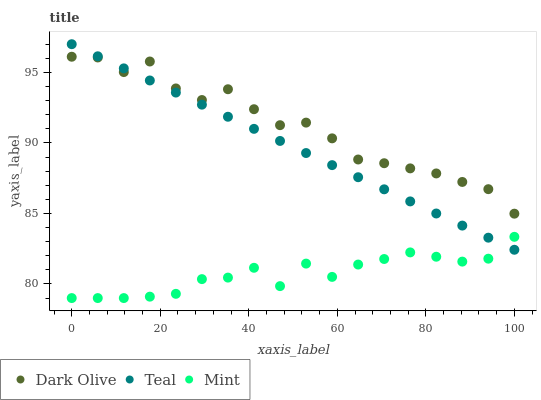Does Mint have the minimum area under the curve?
Answer yes or no. Yes. Does Dark Olive have the maximum area under the curve?
Answer yes or no. Yes. Does Teal have the minimum area under the curve?
Answer yes or no. No. Does Teal have the maximum area under the curve?
Answer yes or no. No. Is Teal the smoothest?
Answer yes or no. Yes. Is Dark Olive the roughest?
Answer yes or no. Yes. Is Mint the smoothest?
Answer yes or no. No. Is Mint the roughest?
Answer yes or no. No. Does Mint have the lowest value?
Answer yes or no. Yes. Does Teal have the lowest value?
Answer yes or no. No. Does Teal have the highest value?
Answer yes or no. Yes. Does Mint have the highest value?
Answer yes or no. No. Is Mint less than Dark Olive?
Answer yes or no. Yes. Is Dark Olive greater than Mint?
Answer yes or no. Yes. Does Dark Olive intersect Teal?
Answer yes or no. Yes. Is Dark Olive less than Teal?
Answer yes or no. No. Is Dark Olive greater than Teal?
Answer yes or no. No. Does Mint intersect Dark Olive?
Answer yes or no. No. 